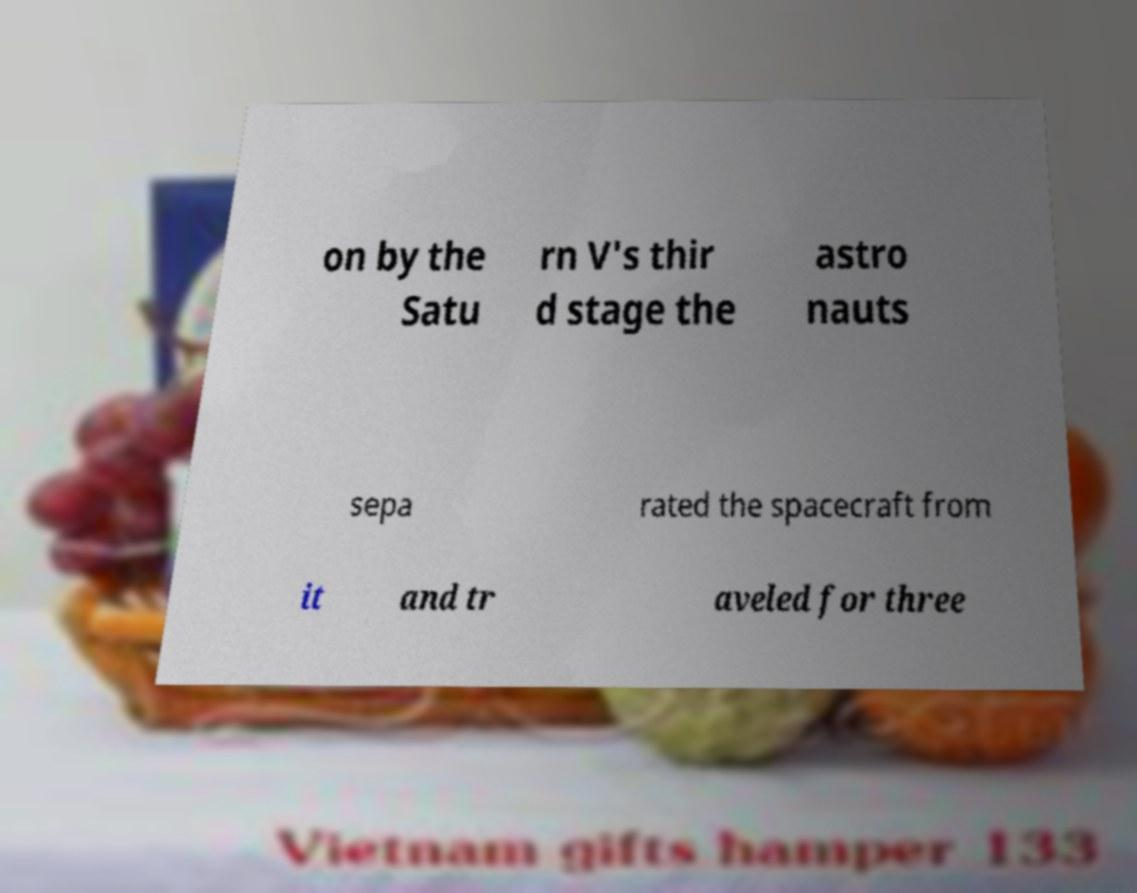Please identify and transcribe the text found in this image. on by the Satu rn V's thir d stage the astro nauts sepa rated the spacecraft from it and tr aveled for three 